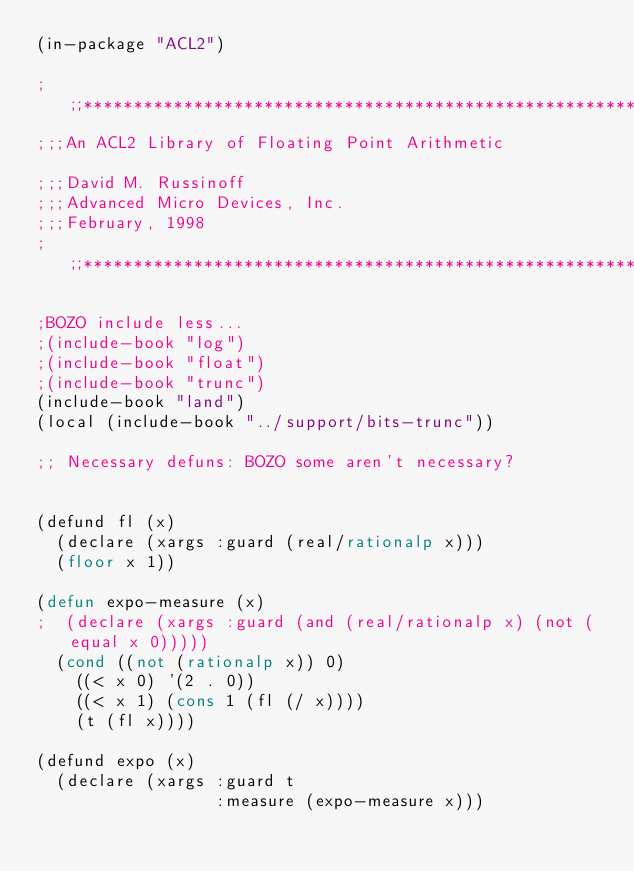Convert code to text. <code><loc_0><loc_0><loc_500><loc_500><_Lisp_>(in-package "ACL2")

;;;***************************************************************
;;;An ACL2 Library of Floating Point Arithmetic

;;;David M. Russinoff
;;;Advanced Micro Devices, Inc.
;;;February, 1998
;;;***************************************************************

;BOZO include less...
;(include-book "log")
;(include-book "float")
;(include-book "trunc")
(include-book "land")
(local (include-book "../support/bits-trunc"))

;; Necessary defuns: BOZO some aren't necessary?


(defund fl (x)
  (declare (xargs :guard (real/rationalp x)))
  (floor x 1))

(defun expo-measure (x)
;  (declare (xargs :guard (and (real/rationalp x) (not (equal x 0)))))
  (cond ((not (rationalp x)) 0)
	((< x 0) '(2 . 0))
	((< x 1) (cons 1 (fl (/ x))))
	(t (fl x))))

(defund expo (x)
  (declare (xargs :guard t
                  :measure (expo-measure x)))</code> 